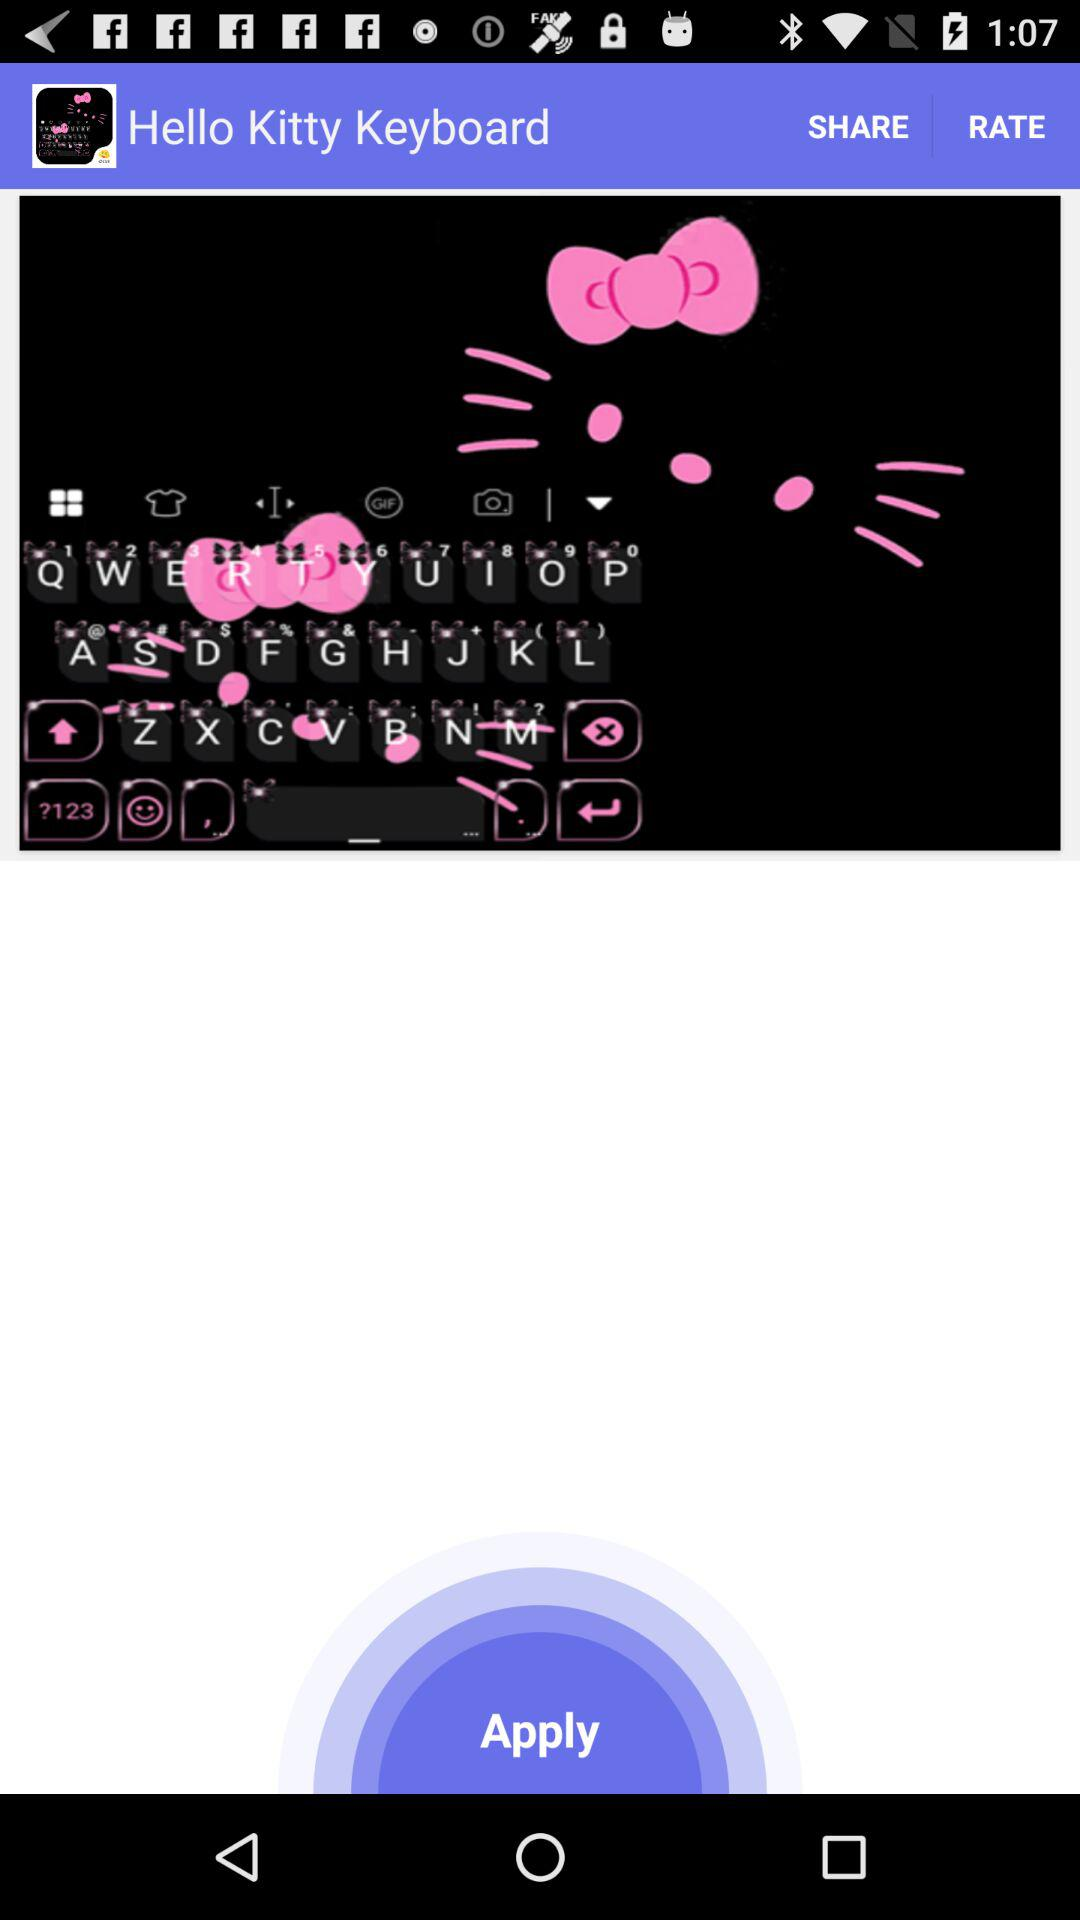What is the application name? The application name is "Hello Kitty Keyboard". 